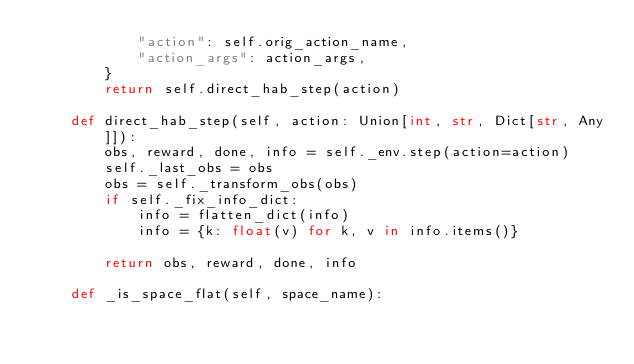<code> <loc_0><loc_0><loc_500><loc_500><_Python_>            "action": self.orig_action_name,
            "action_args": action_args,
        }
        return self.direct_hab_step(action)

    def direct_hab_step(self, action: Union[int, str, Dict[str, Any]]):
        obs, reward, done, info = self._env.step(action=action)
        self._last_obs = obs
        obs = self._transform_obs(obs)
        if self._fix_info_dict:
            info = flatten_dict(info)
            info = {k: float(v) for k, v in info.items()}

        return obs, reward, done, info

    def _is_space_flat(self, space_name):</code> 